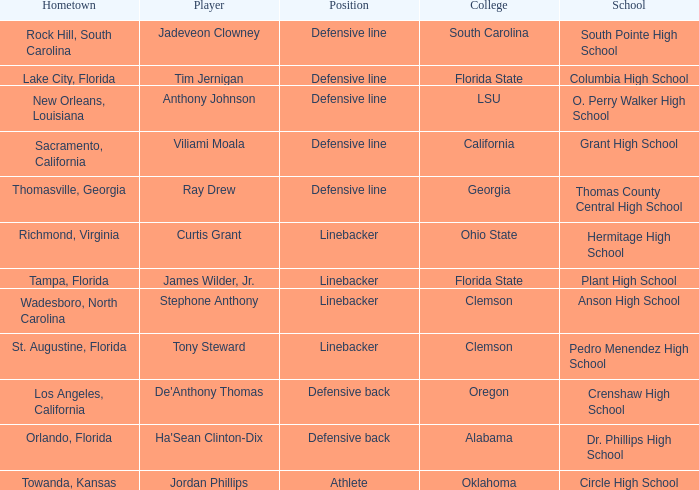Which college is Jordan Phillips playing for? Oklahoma. 